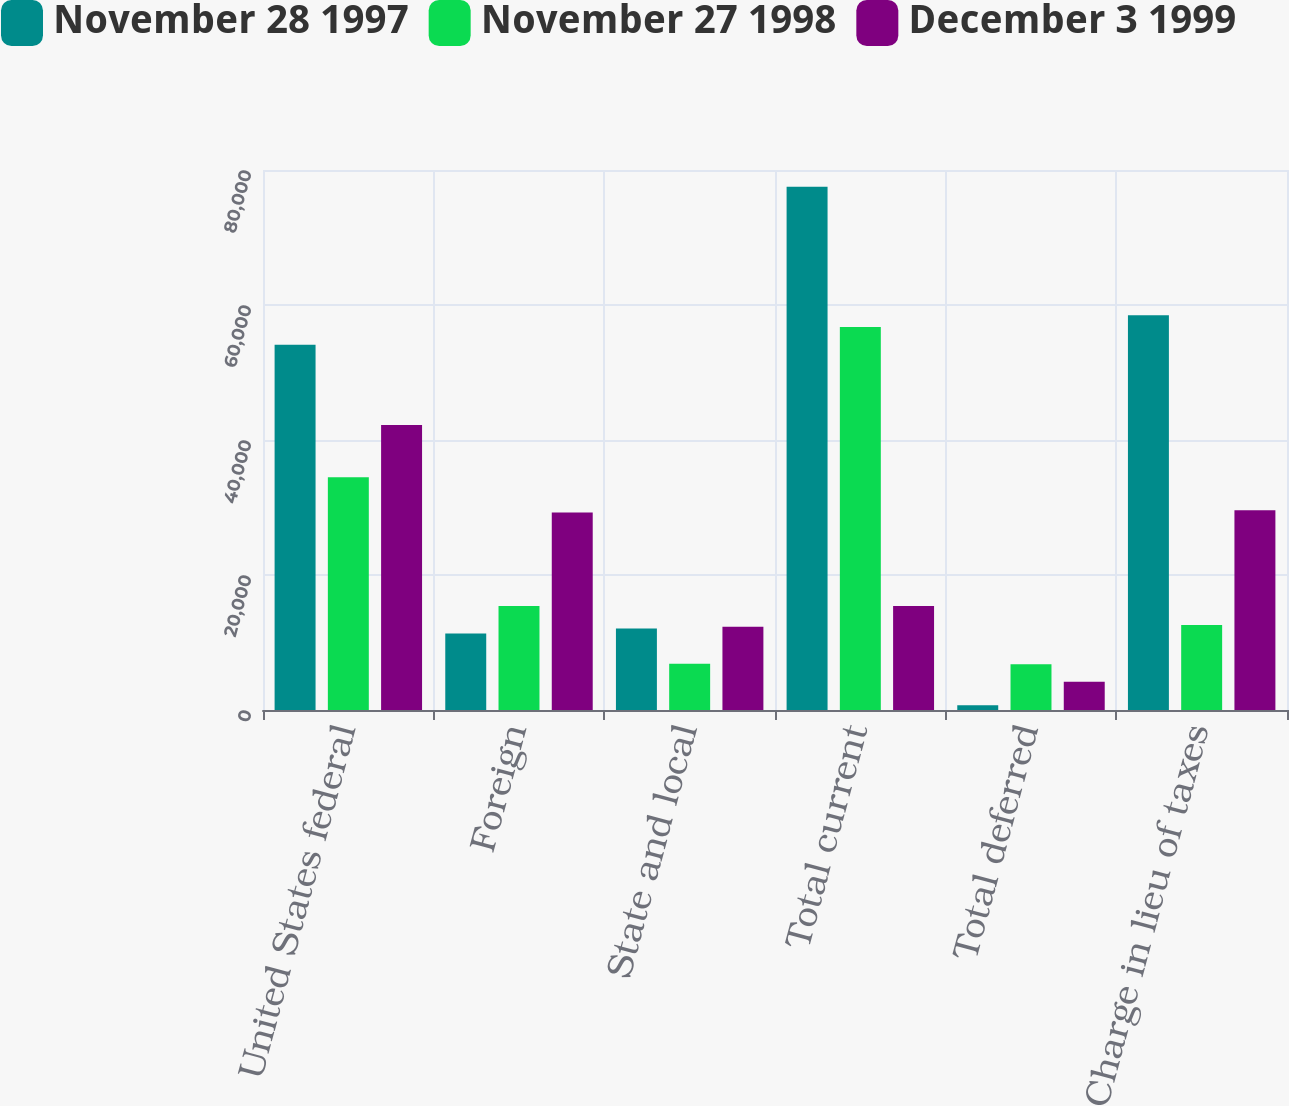Convert chart. <chart><loc_0><loc_0><loc_500><loc_500><stacked_bar_chart><ecel><fcel>United States federal<fcel>Foreign<fcel>State and local<fcel>Total current<fcel>Total deferred<fcel>Charge in lieu of taxes<nl><fcel>November 28 1997<fcel>54097<fcel>11346<fcel>12061<fcel>77504<fcel>694<fcel>58478<nl><fcel>November 27 1998<fcel>34466<fcel>15394<fcel>6869<fcel>56729<fcel>6774<fcel>12595<nl><fcel>December 3 1999<fcel>42238<fcel>29260<fcel>12320<fcel>15394<fcel>4172<fcel>29607<nl></chart> 